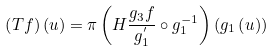<formula> <loc_0><loc_0><loc_500><loc_500>\left ( T f \right ) \left ( u \right ) = \pi \left ( H \frac { g _ { 3 } f } { g _ { 1 } ^ { ^ { \prime } } } \circ g _ { 1 } ^ { - 1 } \right ) \left ( g _ { 1 } \left ( u \right ) \right )</formula> 